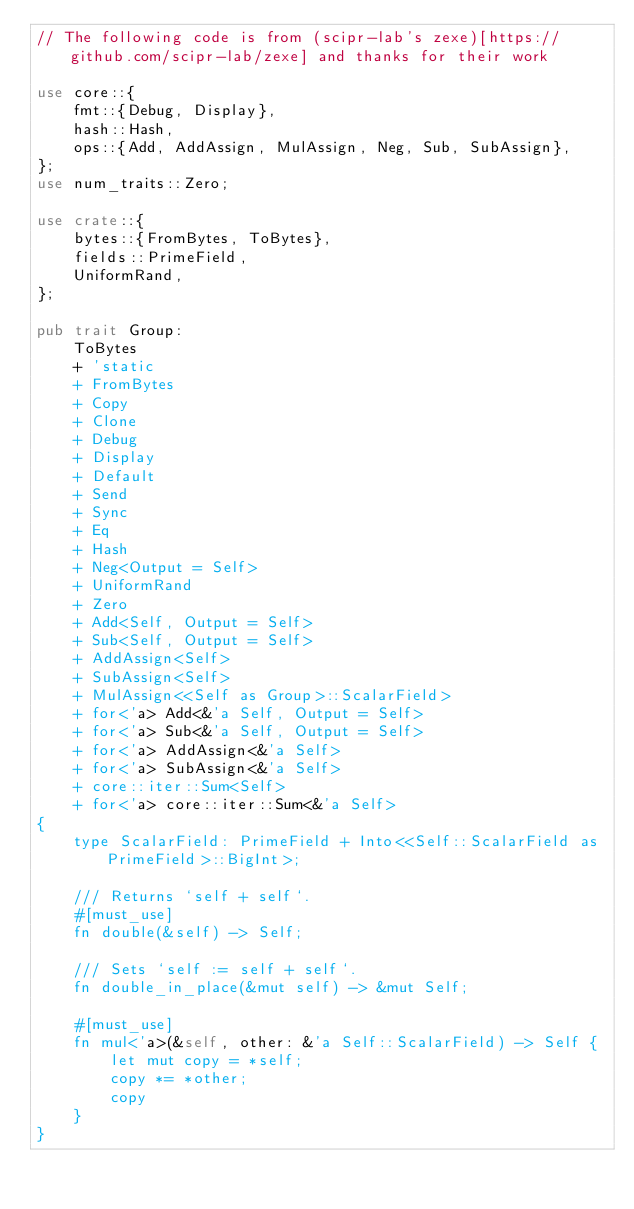<code> <loc_0><loc_0><loc_500><loc_500><_Rust_>// The following code is from (scipr-lab's zexe)[https://github.com/scipr-lab/zexe] and thanks for their work

use core::{
    fmt::{Debug, Display},
    hash::Hash,
    ops::{Add, AddAssign, MulAssign, Neg, Sub, SubAssign},
};
use num_traits::Zero;

use crate::{
    bytes::{FromBytes, ToBytes},
    fields::PrimeField,
    UniformRand,
};

pub trait Group:
    ToBytes
    + 'static
    + FromBytes
    + Copy
    + Clone
    + Debug
    + Display
    + Default
    + Send
    + Sync
    + Eq
    + Hash
    + Neg<Output = Self>
    + UniformRand
    + Zero
    + Add<Self, Output = Self>
    + Sub<Self, Output = Self>
    + AddAssign<Self>
    + SubAssign<Self>
    + MulAssign<<Self as Group>::ScalarField>
    + for<'a> Add<&'a Self, Output = Self>
    + for<'a> Sub<&'a Self, Output = Self>
    + for<'a> AddAssign<&'a Self>
    + for<'a> SubAssign<&'a Self>
    + core::iter::Sum<Self>
    + for<'a> core::iter::Sum<&'a Self>
{
    type ScalarField: PrimeField + Into<<Self::ScalarField as PrimeField>::BigInt>;

    /// Returns `self + self`.
    #[must_use]
    fn double(&self) -> Self;

    /// Sets `self := self + self`.
    fn double_in_place(&mut self) -> &mut Self;

    #[must_use]
    fn mul<'a>(&self, other: &'a Self::ScalarField) -> Self {
        let mut copy = *self;
        copy *= *other;
        copy
    }
}
</code> 